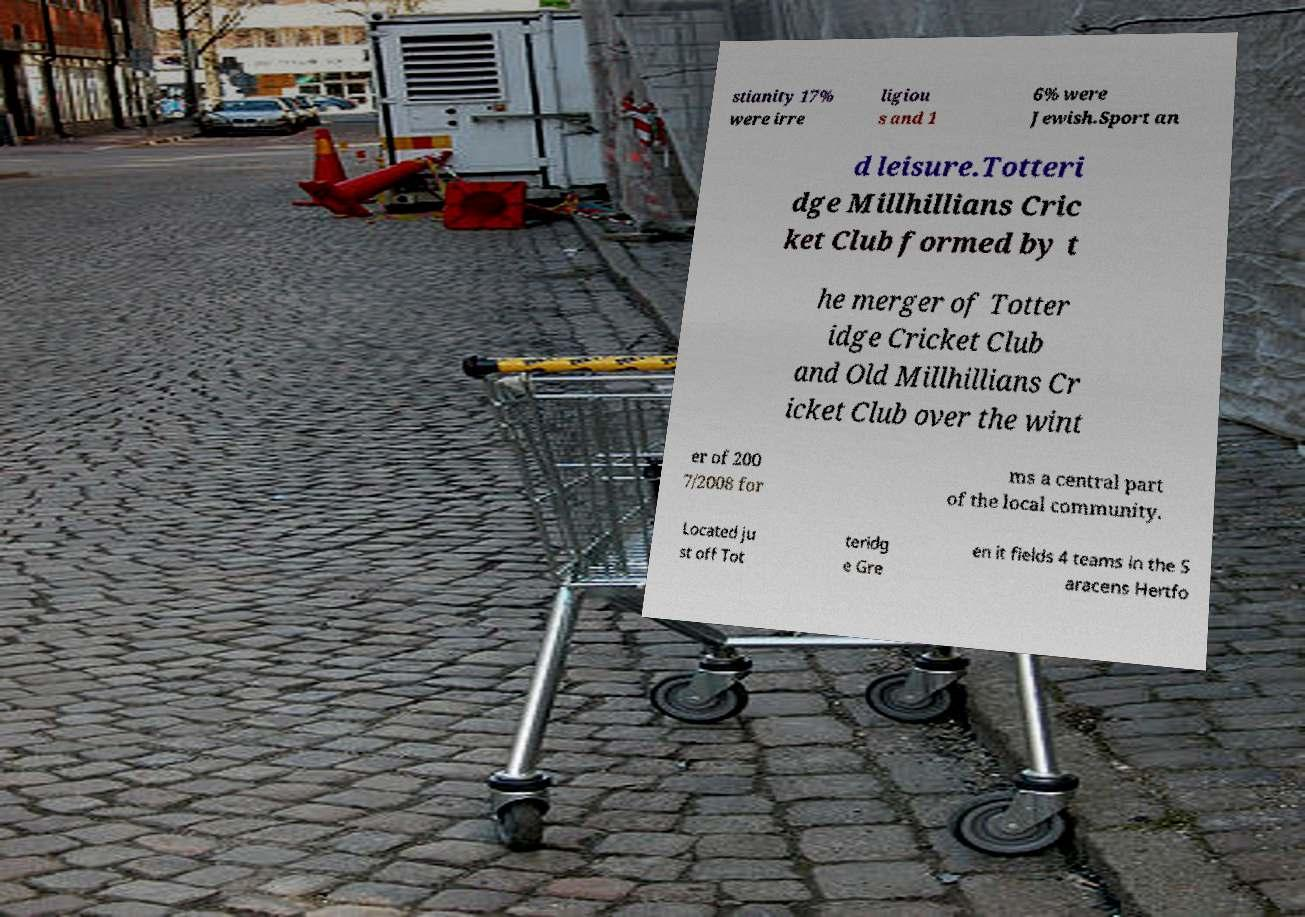Can you read and provide the text displayed in the image?This photo seems to have some interesting text. Can you extract and type it out for me? stianity 17% were irre ligiou s and 1 6% were Jewish.Sport an d leisure.Totteri dge Millhillians Cric ket Club formed by t he merger of Totter idge Cricket Club and Old Millhillians Cr icket Club over the wint er of 200 7/2008 for ms a central part of the local community. Located ju st off Tot teridg e Gre en it fields 4 teams in the S aracens Hertfo 